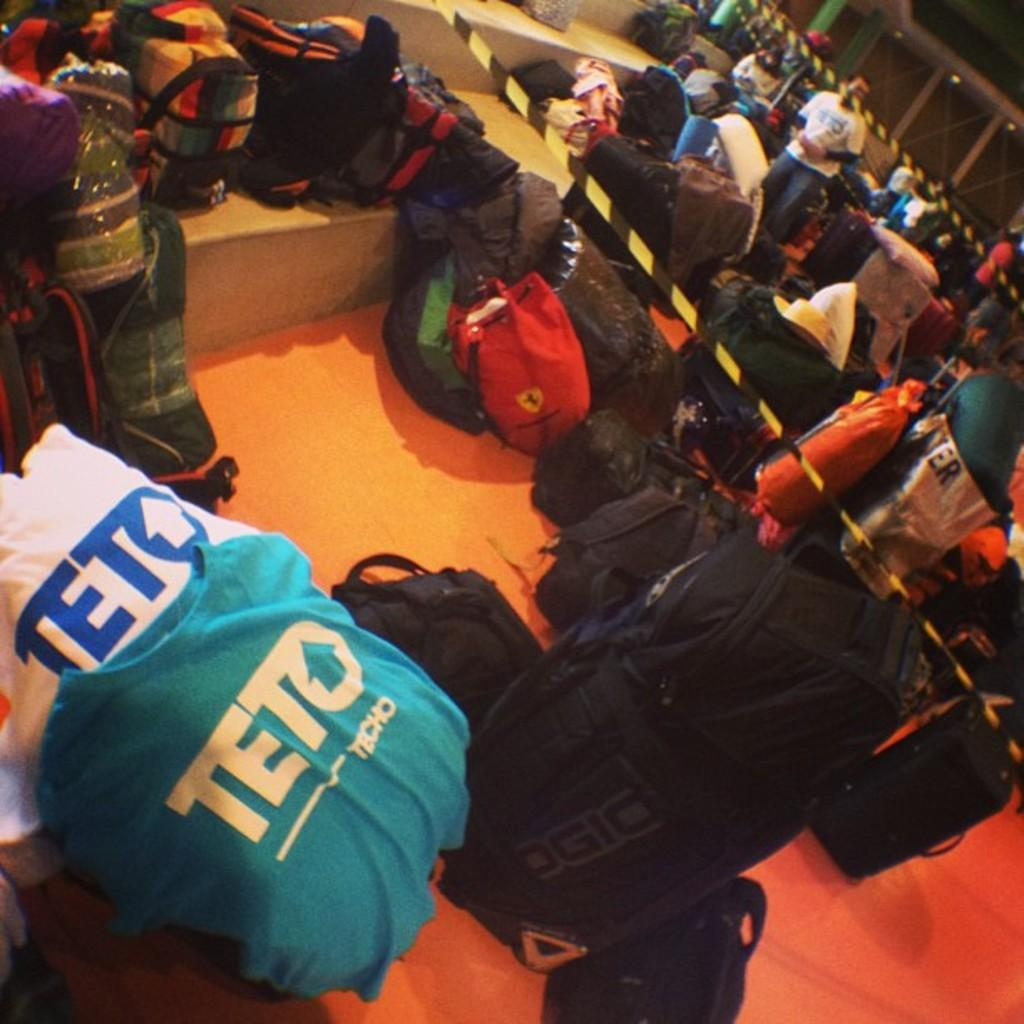<image>
Create a compact narrative representing the image presented. Several Teto shirts are laid out next to a bunch of luggage. 